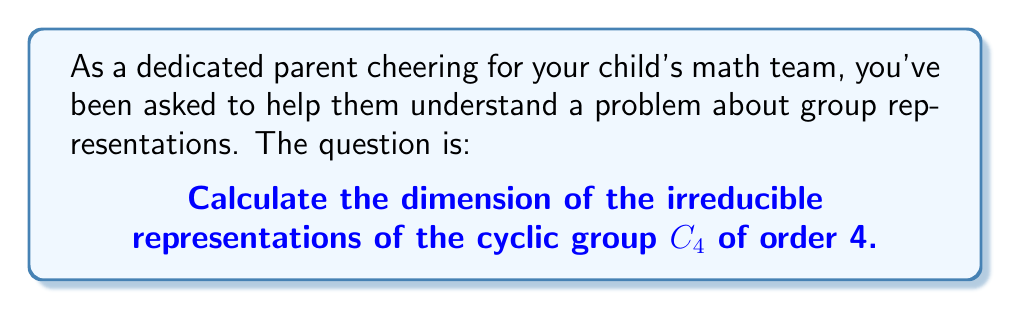Teach me how to tackle this problem. Let's approach this step-by-step:

1) First, recall that for any finite group $G$, the sum of the squares of the dimensions of its irreducible representations is equal to the order of the group. This is known as the "sum of squares formula":

   $$\sum_{i=1}^k d_i^2 = |G|$$

   where $d_i$ are the dimensions of the irreducible representations and $|G|$ is the order of the group.

2) For $C_4$, we know that $|G| = 4$.

3) Next, remember that for cyclic groups, all irreducible representations are 1-dimensional. This is because cyclic groups are abelian, and all irreducible representations of abelian groups are 1-dimensional.

4) So, we are looking for the number of 1-dimensional representations that satisfy the sum of squares formula:

   $$\sum_{i=1}^k 1^2 = 4$$

5) This equation is simply:

   $$k = 4$$

6) Therefore, $C_4$ has 4 irreducible representations, each of dimension 1.

As a supportive parent, you can encourage your child by pointing out how understanding these fundamental principles can make seemingly complex problems much more manageable!
Answer: 1 